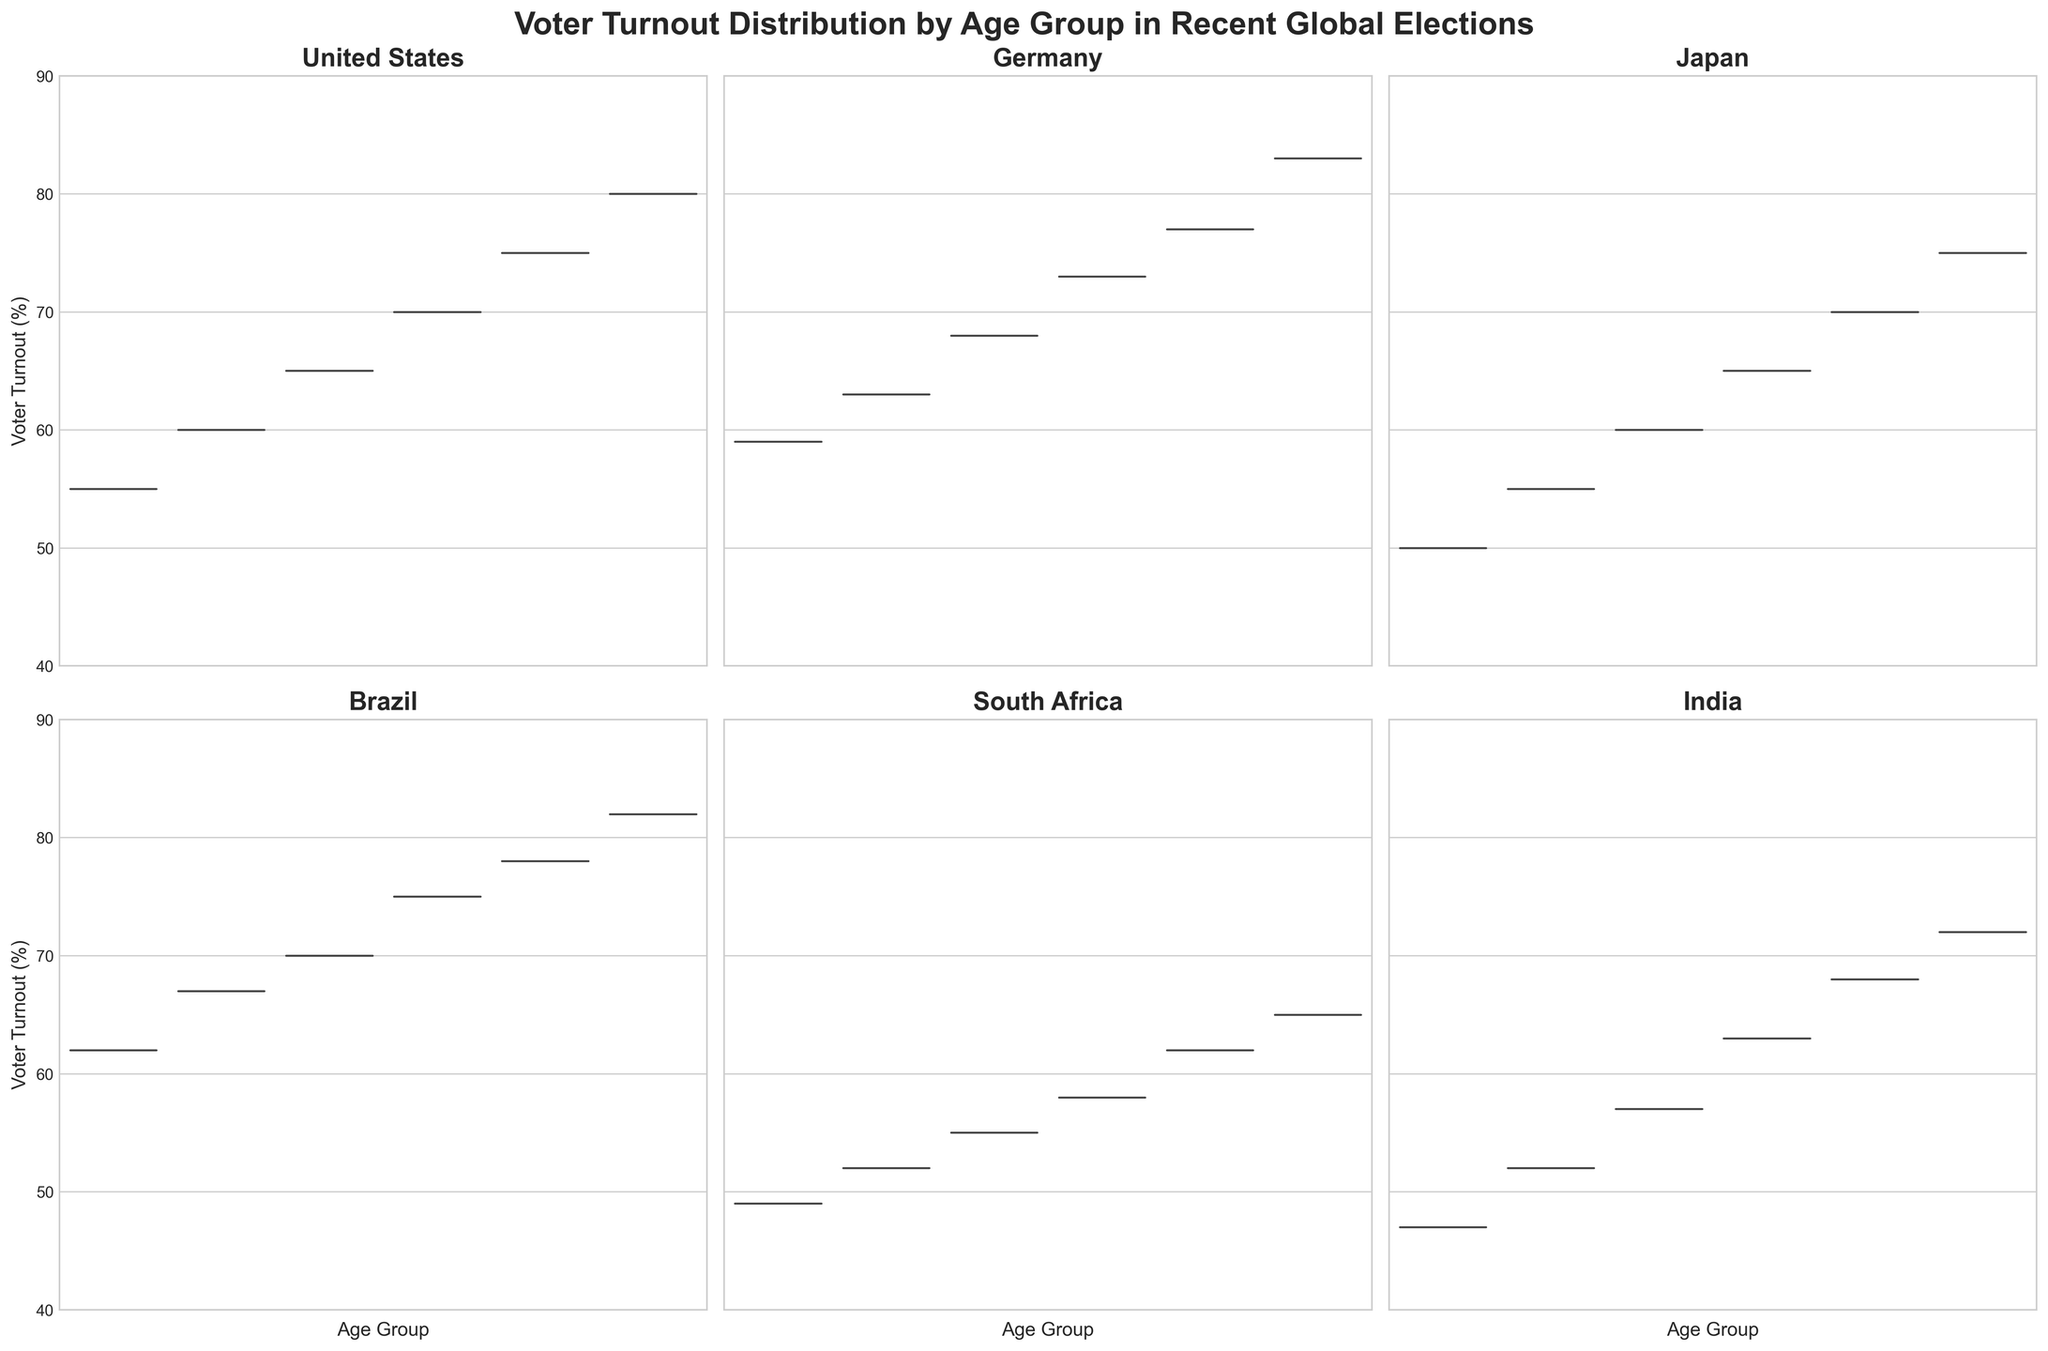What is the title of the figure? The title is displayed at the top of the figure and reads "Voter Turnout Distribution by Age Group in Recent Global Elections".
Answer: Voter Turnout Distribution by Age Group in Recent Global Elections Which country has the highest voter turnout for the 18-24 age group? Looking at each subplot, Brazil shows the highest voter turnout for the 18-24 age group at approximately 62%.
Answer: Brazil Compare the voter turnout between the 25-34 and 55-64 age groups in the United States. Which age group has higher voter turnout? In the United States subplot, the 25-34 age group has a voter turnout of about 60%, while the 55-64 age group has about 75%. The 55-64 age group has a higher voter turnout.
Answer: 55-64 What is the range of voter turnout (%) for Japan across all age groups? In Japan's subplot, the lowest turnout is in the 18-24 age group at 50%, and the highest is in the 65+ age group at 75%. Therefore, the range is 75% - 50% = 25%.
Answer: 25% Which age group shows the most consistent high voter turnout across all countries? By examining all subplots, the 65+ age group consistently shows high voter turnout across all countries, with values ranging from 65% to 83%.
Answer: 65+ For Germany, what is the voter turnout discrepancy between the youngest and oldest age groups? In Germany's subplot, the 18-24 age group has a voter turnout of approximately 59%, and the 65+ age group has approximately 83%. The discrepancy is 83% - 59% = 24%.
Answer: 24% What trend can be observed about voter turnout across different age groups in South Africa? South Africa shows a progressively increasing trend in voter turnout as the age group increases, starting from around 49% in the 18-24 age group and reaching about 65% in the 65+ age group.
Answer: Increasing trend Which country exhibits the smallest difference in voter turnout between any two consecutive age groups? India's subplot shows a relatively small and consistent increase between consecutive age groups, specifically between the 18-24 and 25-34 age groups, with a difference of 52% - 47% = 5%.
Answer: India 